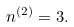<formula> <loc_0><loc_0><loc_500><loc_500>n ^ { ( 2 ) } = 3 .</formula> 